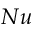<formula> <loc_0><loc_0><loc_500><loc_500>N u</formula> 